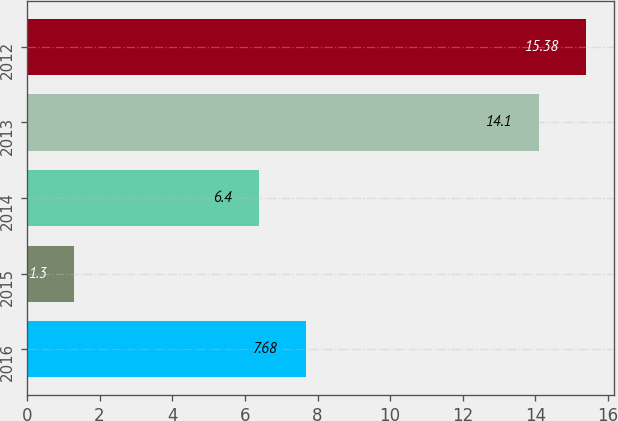Convert chart. <chart><loc_0><loc_0><loc_500><loc_500><bar_chart><fcel>2016<fcel>2015<fcel>2014<fcel>2013<fcel>2012<nl><fcel>7.68<fcel>1.3<fcel>6.4<fcel>14.1<fcel>15.38<nl></chart> 